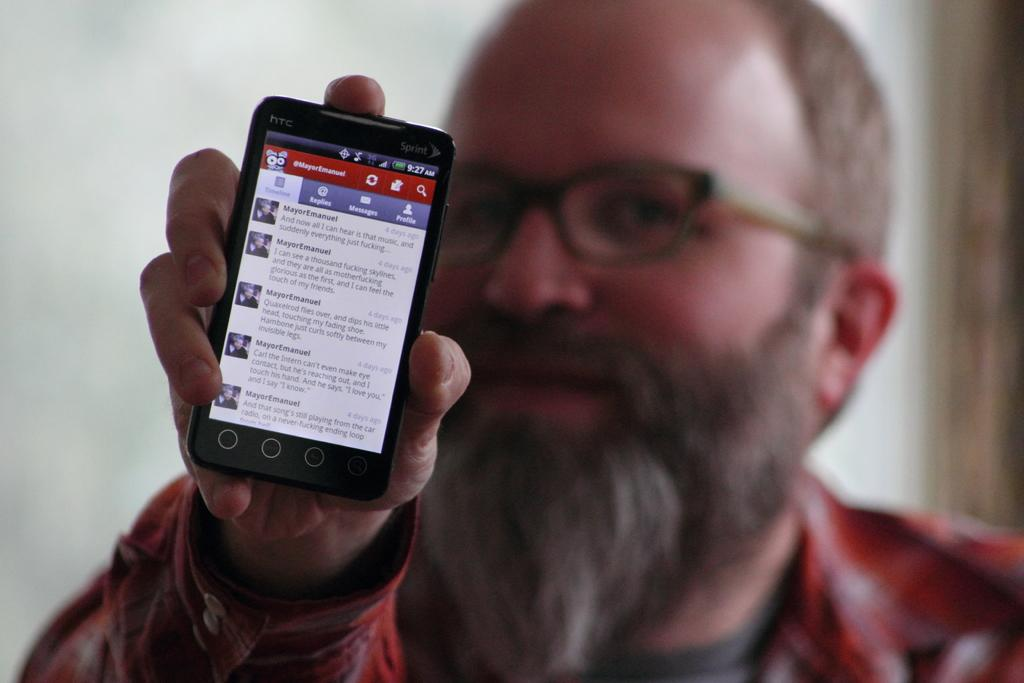What is the man in the image doing? The man is holding a phone in the image. What accessory is the man wearing? The man is wearing glasses (specs) in the image. What type of vest is the man wearing in the image? There is no vest visible in the image; the man is only wearing glasses (specs) and holding a phone. 